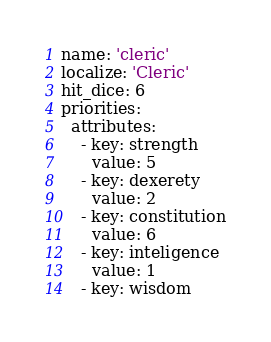Convert code to text. <code><loc_0><loc_0><loc_500><loc_500><_YAML_>name: 'cleric'
localize: 'Cleric'
hit_dice: 6
priorities:
  attributes:
    - key: strength
      value: 5
    - key: dexerety
      value: 2
    - key: constitution
      value: 6
    - key: inteligence
      value: 1
    - key: wisdom</code> 